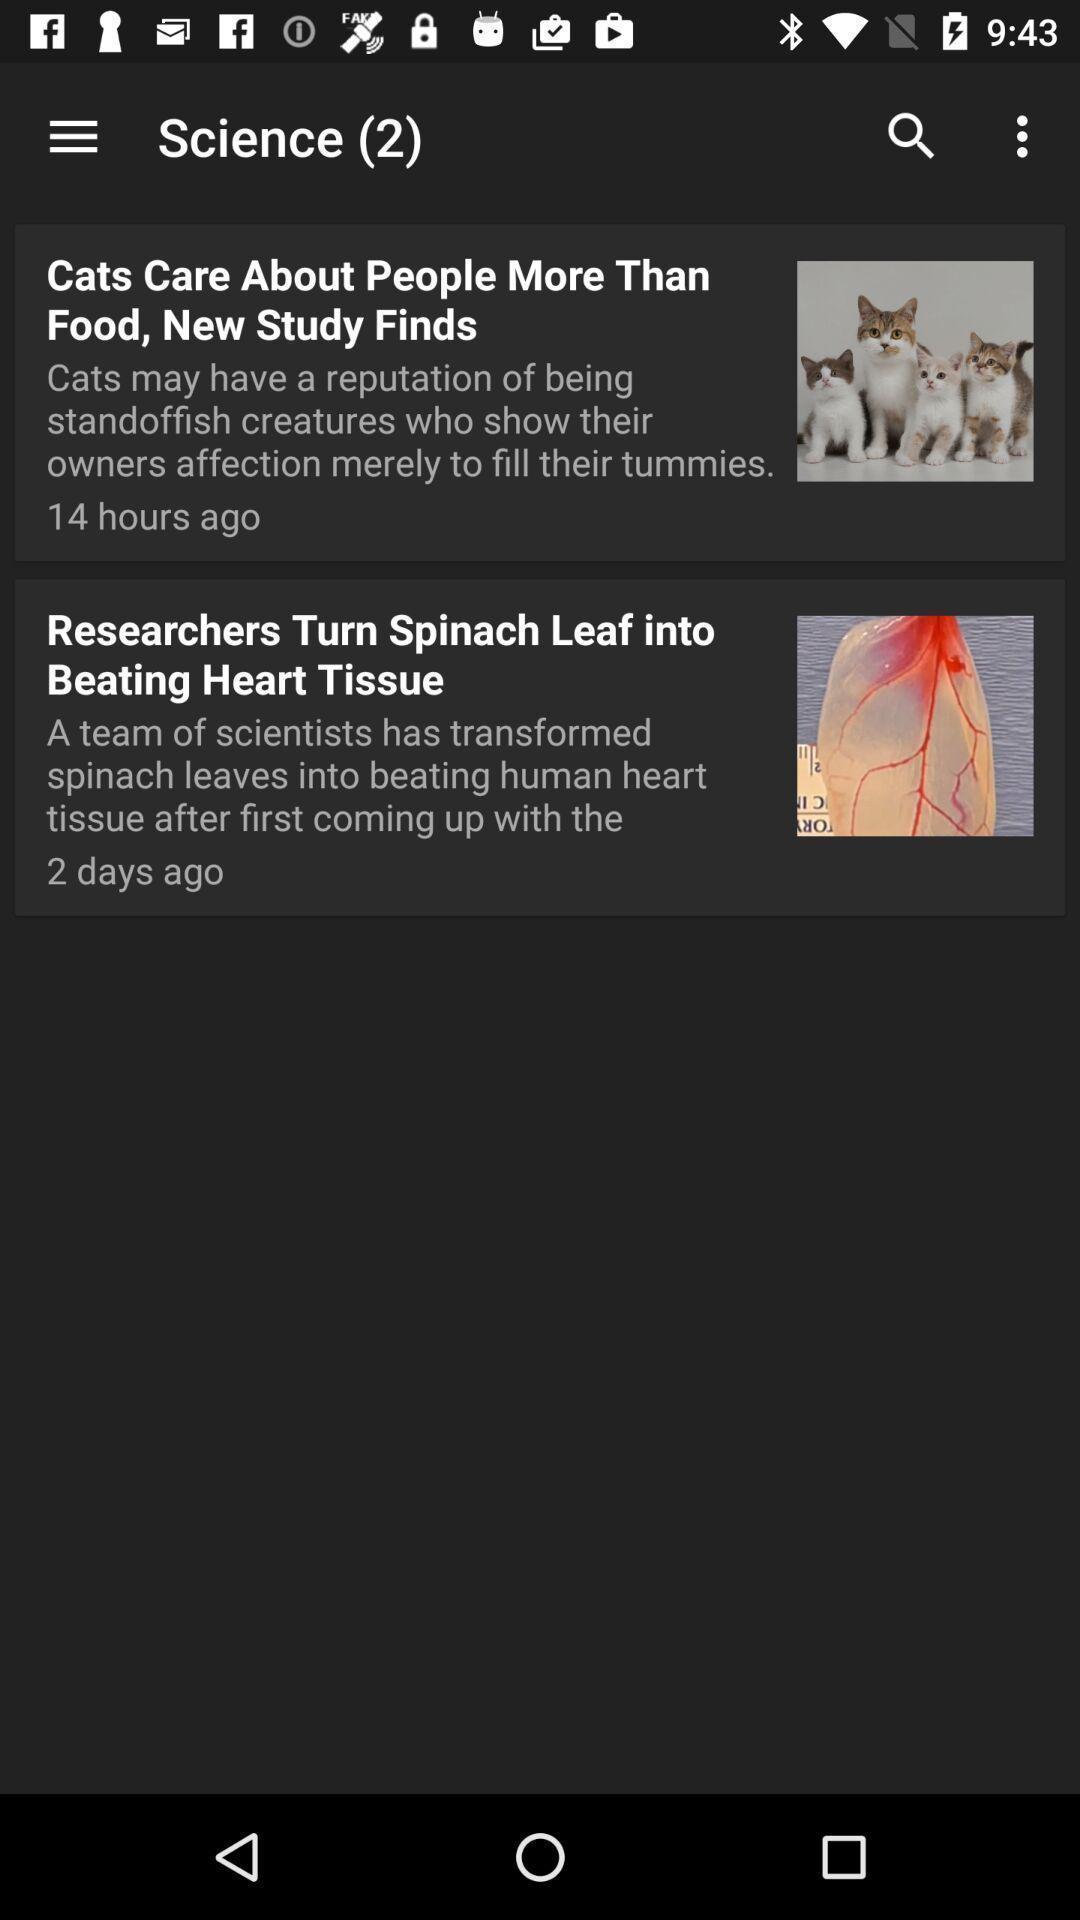Give me a summary of this screen capture. Page showing list of news. 